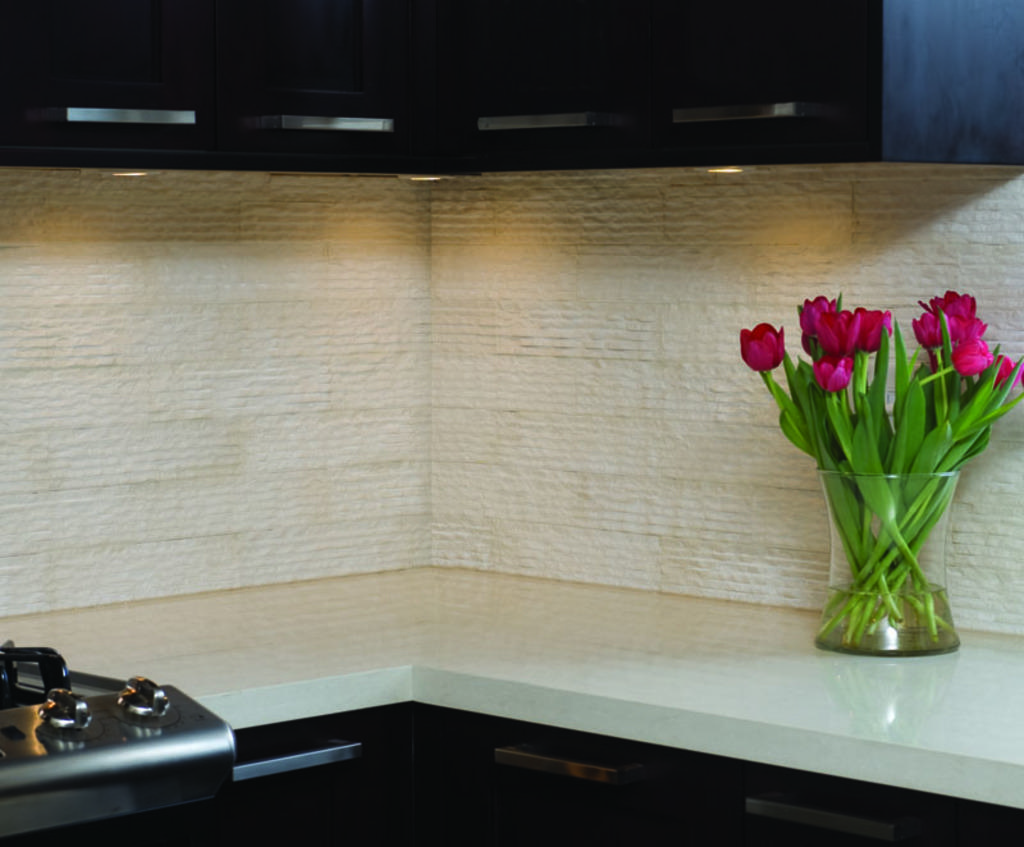What is contained in the glass vase in the image? There are flowers in a glass vase in the image. Where are the flowers placed? The flowers are on a platform in the image. What can be seen in the background of the image? The background of the image is dark. Can you describe a specific object in the image? There is a black object in the image. Is there a mountain visible in the image? No, there is no mountain present in the image. Can you describe the motion of the flowers in the image? The flowers are stationary in the glass vase and do not exhibit any motion in the image. 